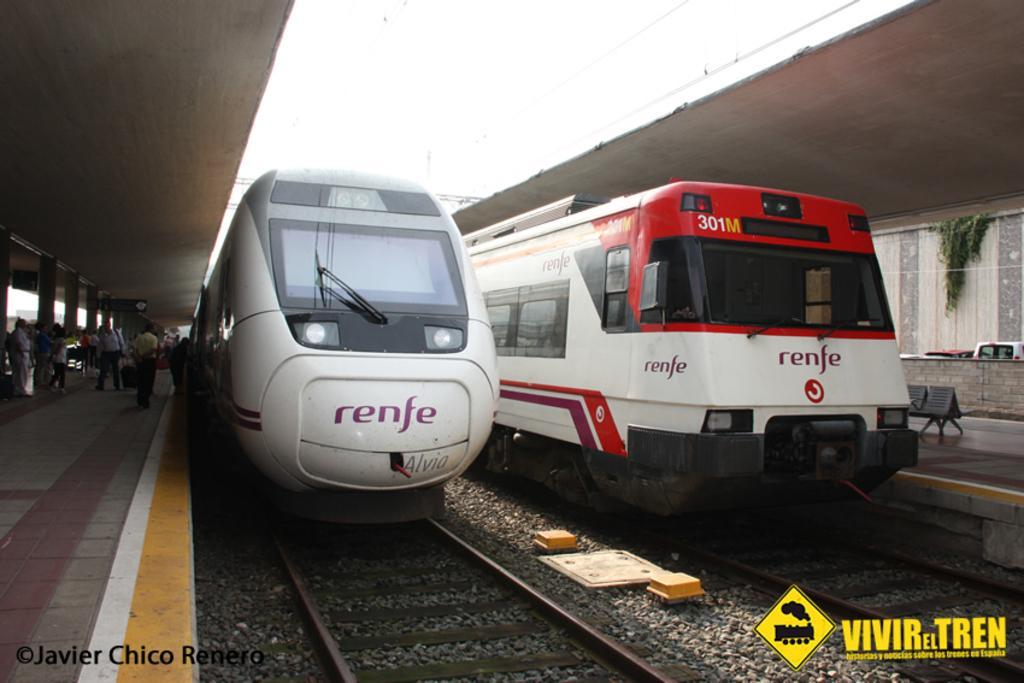How would you summarize this image in a sentence or two? In the center of the image we can see trains on the railway tracks. On the left side of the image we can see persons on the platform. On the right side of the image we can see chairs, platform and vehicle. In the background there is sky. 